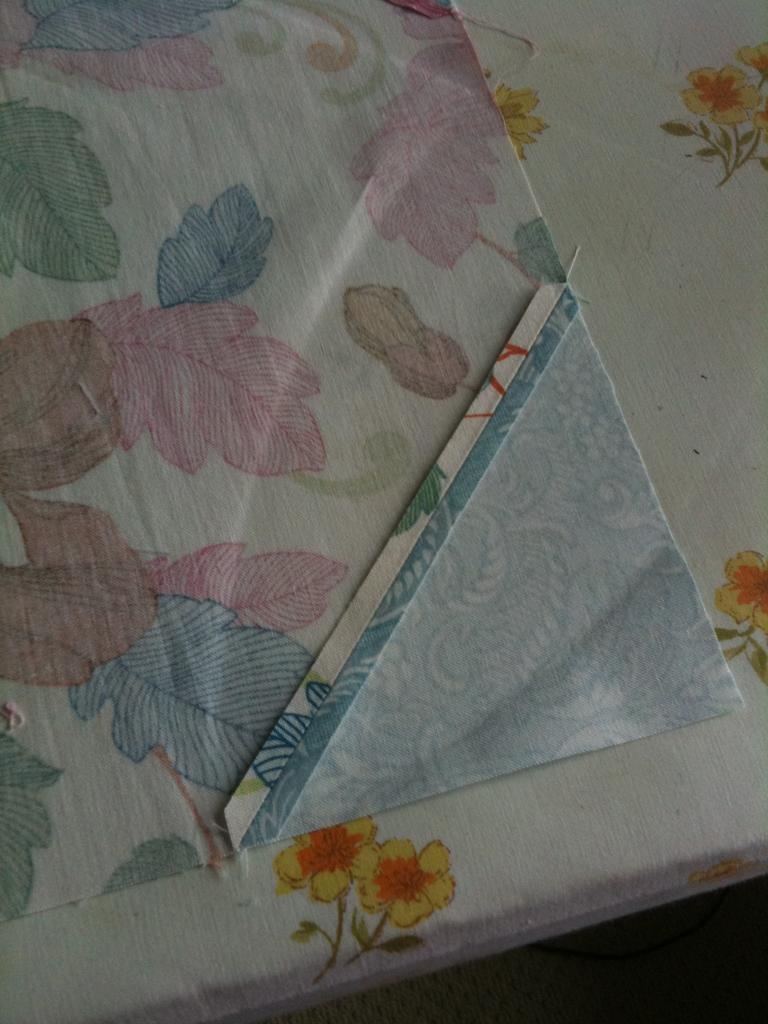How would you summarize this image in a sentence or two? In this image I can see a cloth which is in white color, on the cloth I can see few multicolor leaves and the cloth is on the white color surface. I can also see few flowers in orange and yellow color. 